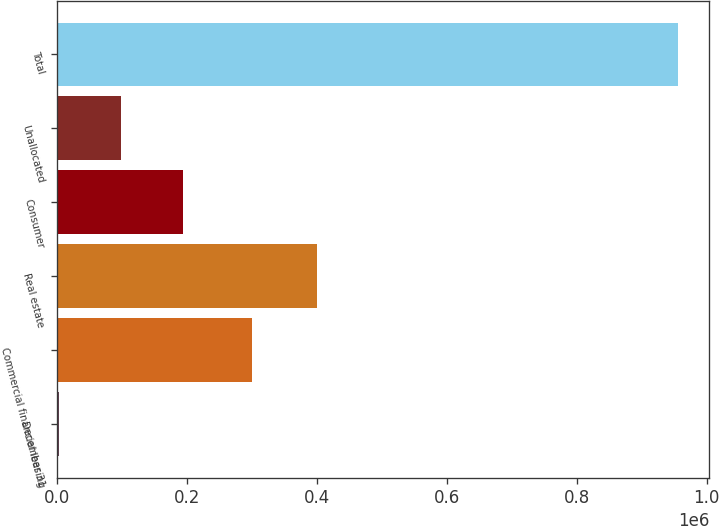Convert chart to OTSL. <chart><loc_0><loc_0><loc_500><loc_500><bar_chart><fcel>December 31<fcel>Commercial financial leasing<fcel>Real estate<fcel>Consumer<fcel>Unallocated<fcel>Total<nl><fcel>2015<fcel>300404<fcel>399069<fcel>192810<fcel>97412.7<fcel>955992<nl></chart> 